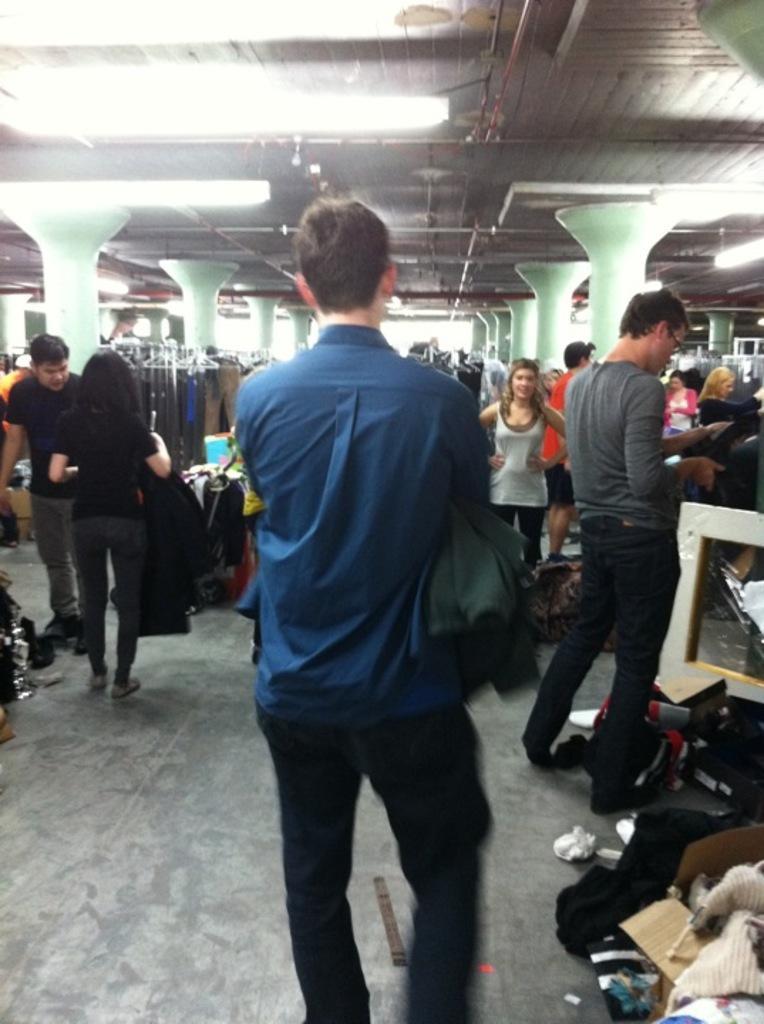Please provide a concise description of this image. In the middle of the image, there is a person in violet color shirt, holding an object and standing. In the background, there are other persons, there are pillars, there are clothes arranged and there are lights attached to the roof. 